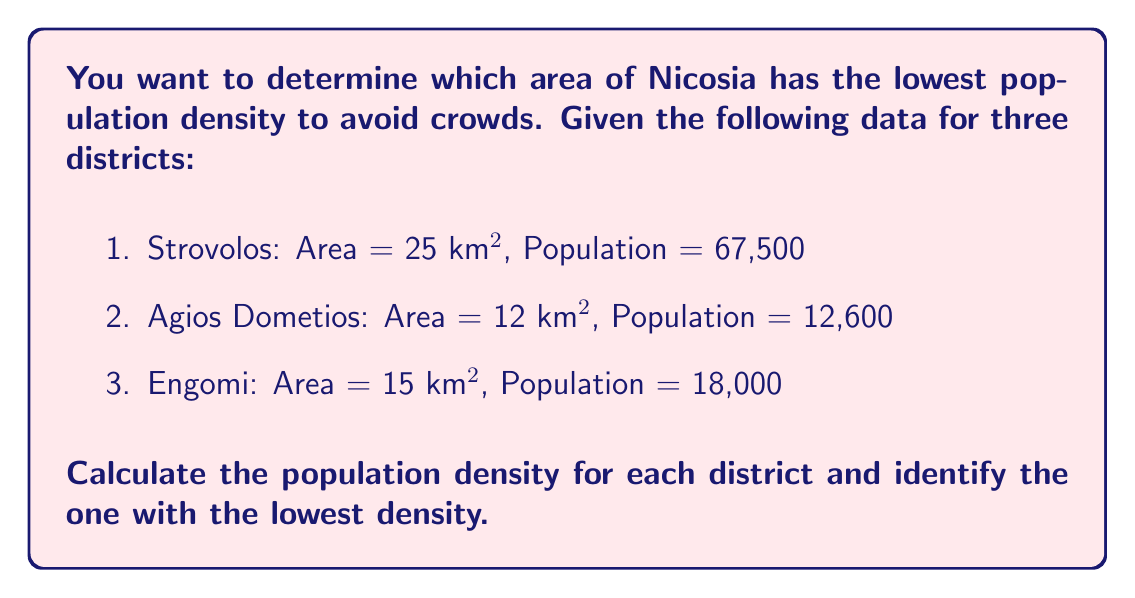Teach me how to tackle this problem. To solve this problem, we need to calculate the population density for each district and compare them. Population density is defined as the number of people per unit area, typically expressed as people per square kilometer (people/km²).

The formula for population density is:

$$\text{Population Density} = \frac{\text{Population}}{\text{Area}}$$

Let's calculate the population density for each district:

1. Strovolos:
   $$\text{Density}_{\text{Strovolos}} = \frac{67,500}{25} = 2,700 \text{ people/km²}$$

2. Agios Dometios:
   $$\text{Density}_{\text{Agios Dometios}} = \frac{12,600}{12} = 1,050 \text{ people/km²}$$

3. Engomi:
   $$\text{Density}_{\text{Engomi}} = \frac{18,000}{15} = 1,200 \text{ people/km²}$$

Comparing the results:
Strovolos: 2,700 people/km²
Agios Dometios: 1,050 people/km²
Engomi: 1,200 people/km²

The district with the lowest population density is Agios Dometios with 1,050 people/km².
Answer: Agios Dometios: 1,050 people/km² 